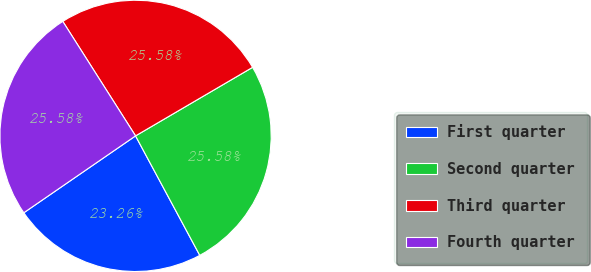Convert chart. <chart><loc_0><loc_0><loc_500><loc_500><pie_chart><fcel>First quarter<fcel>Second quarter<fcel>Third quarter<fcel>Fourth quarter<nl><fcel>23.26%<fcel>25.58%<fcel>25.58%<fcel>25.58%<nl></chart> 